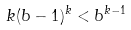<formula> <loc_0><loc_0><loc_500><loc_500>k ( b - 1 ) ^ { k } < b ^ { k - 1 }</formula> 